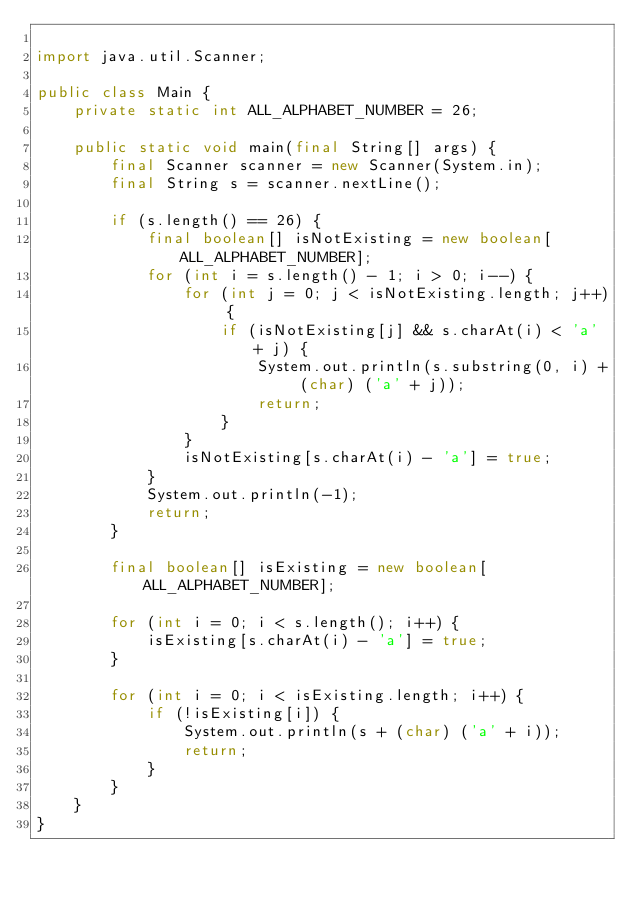Convert code to text. <code><loc_0><loc_0><loc_500><loc_500><_Java_>
import java.util.Scanner;

public class Main {
    private static int ALL_ALPHABET_NUMBER = 26;

    public static void main(final String[] args) {
        final Scanner scanner = new Scanner(System.in);
        final String s = scanner.nextLine();

        if (s.length() == 26) {
            final boolean[] isNotExisting = new boolean[ALL_ALPHABET_NUMBER];
            for (int i = s.length() - 1; i > 0; i--) {
                for (int j = 0; j < isNotExisting.length; j++) {
                    if (isNotExisting[j] && s.charAt(i) < 'a' + j) {
                        System.out.println(s.substring(0, i) + (char) ('a' + j));
                        return;
                    }
                }
                isNotExisting[s.charAt(i) - 'a'] = true;
            }
            System.out.println(-1);
            return;
        }

        final boolean[] isExisting = new boolean[ALL_ALPHABET_NUMBER];

        for (int i = 0; i < s.length(); i++) {
            isExisting[s.charAt(i) - 'a'] = true;
        }

        for (int i = 0; i < isExisting.length; i++) {
            if (!isExisting[i]) {
                System.out.println(s + (char) ('a' + i));
                return;
            }
        }
    }
}
</code> 